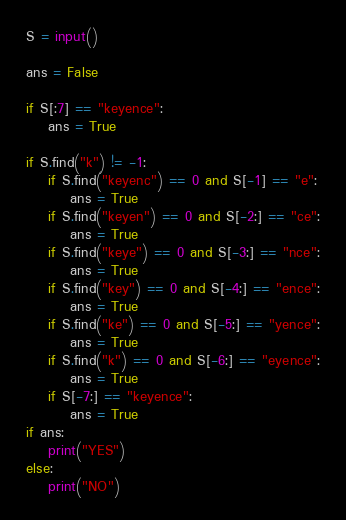Convert code to text. <code><loc_0><loc_0><loc_500><loc_500><_Python_>S = input()

ans = False

if S[:7] == "keyence":
    ans = True

if S.find("k") != -1:
    if S.find("keyenc") == 0 and S[-1] == "e":
        ans = True
    if S.find("keyen") == 0 and S[-2:] == "ce":
        ans = True
    if S.find("keye") == 0 and S[-3:] == "nce":
        ans = True
    if S.find("key") == 0 and S[-4:] == "ence":
        ans = True
    if S.find("ke") == 0 and S[-5:] == "yence":
        ans = True
    if S.find("k") == 0 and S[-6:] == "eyence":
        ans = True
    if S[-7:] == "keyence":
        ans = True
if ans:
    print("YES")
else:
    print("NO")
</code> 